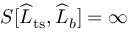<formula> <loc_0><loc_0><loc_500><loc_500>S [ \widehat { L } _ { t s } , \widehat { L } _ { b } ] = \infty</formula> 